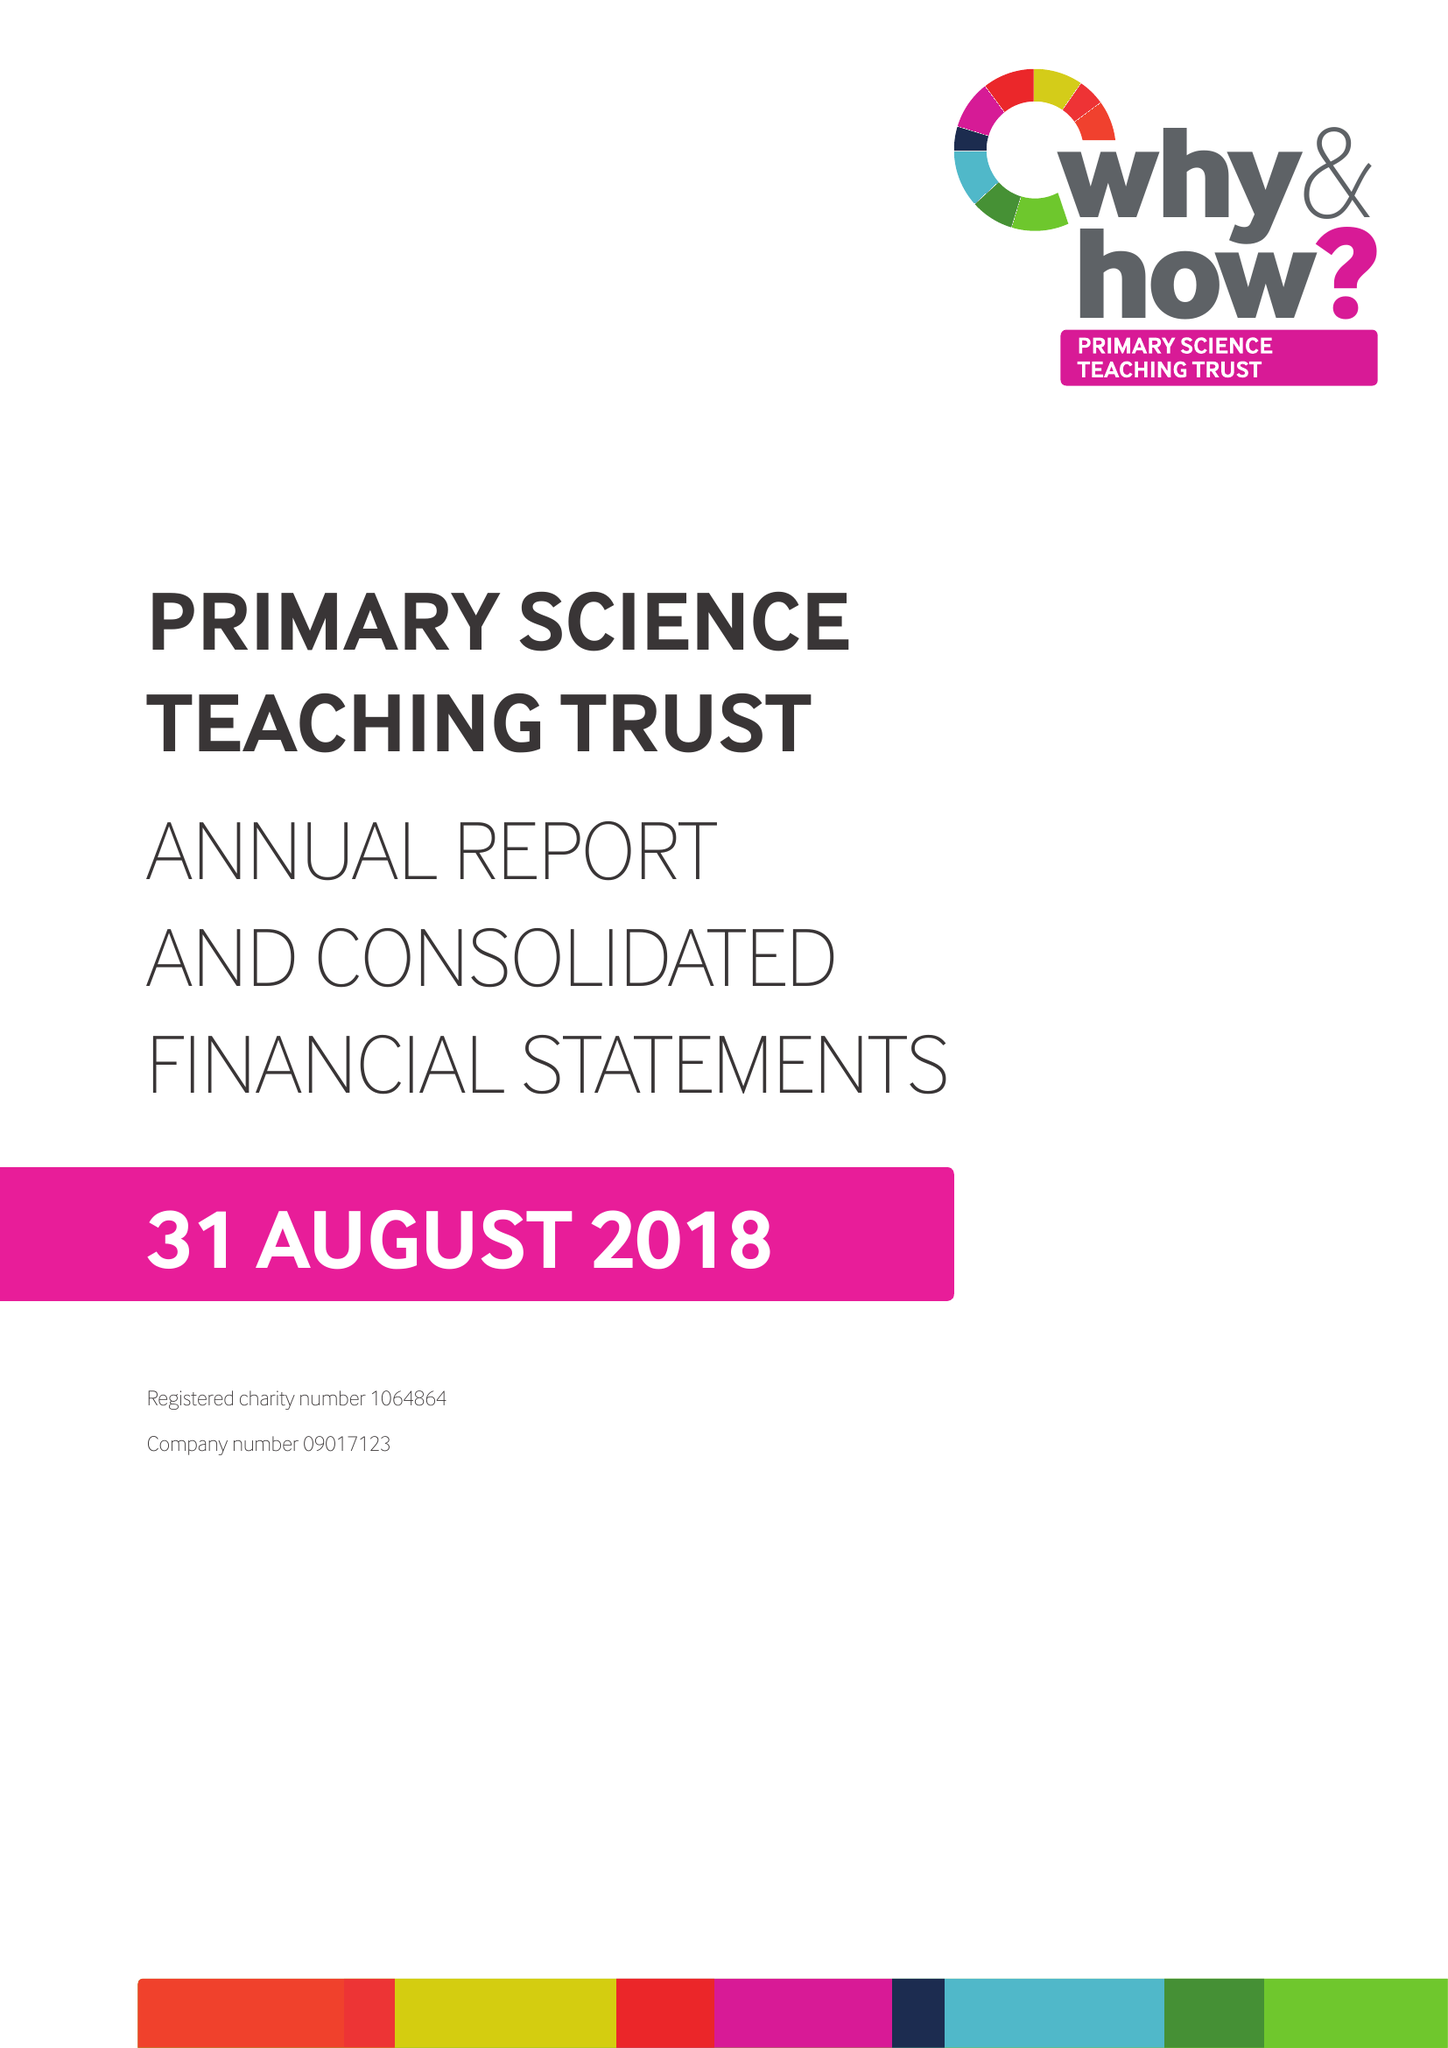What is the value for the address__street_line?
Answer the question using a single word or phrase. None 